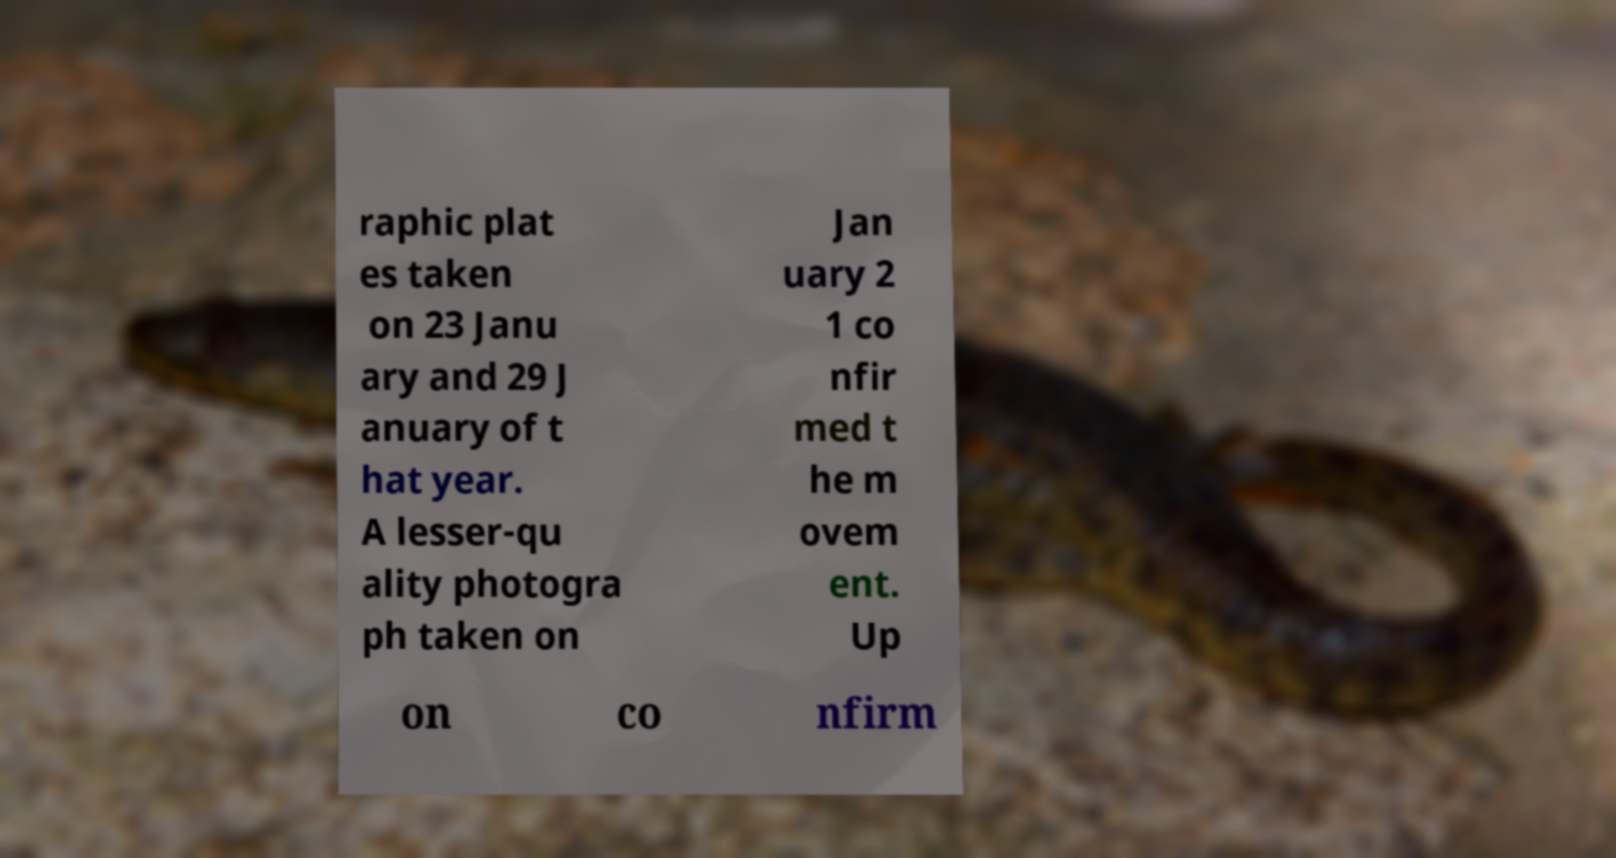Could you assist in decoding the text presented in this image and type it out clearly? raphic plat es taken on 23 Janu ary and 29 J anuary of t hat year. A lesser-qu ality photogra ph taken on Jan uary 2 1 co nfir med t he m ovem ent. Up on co nfirm 